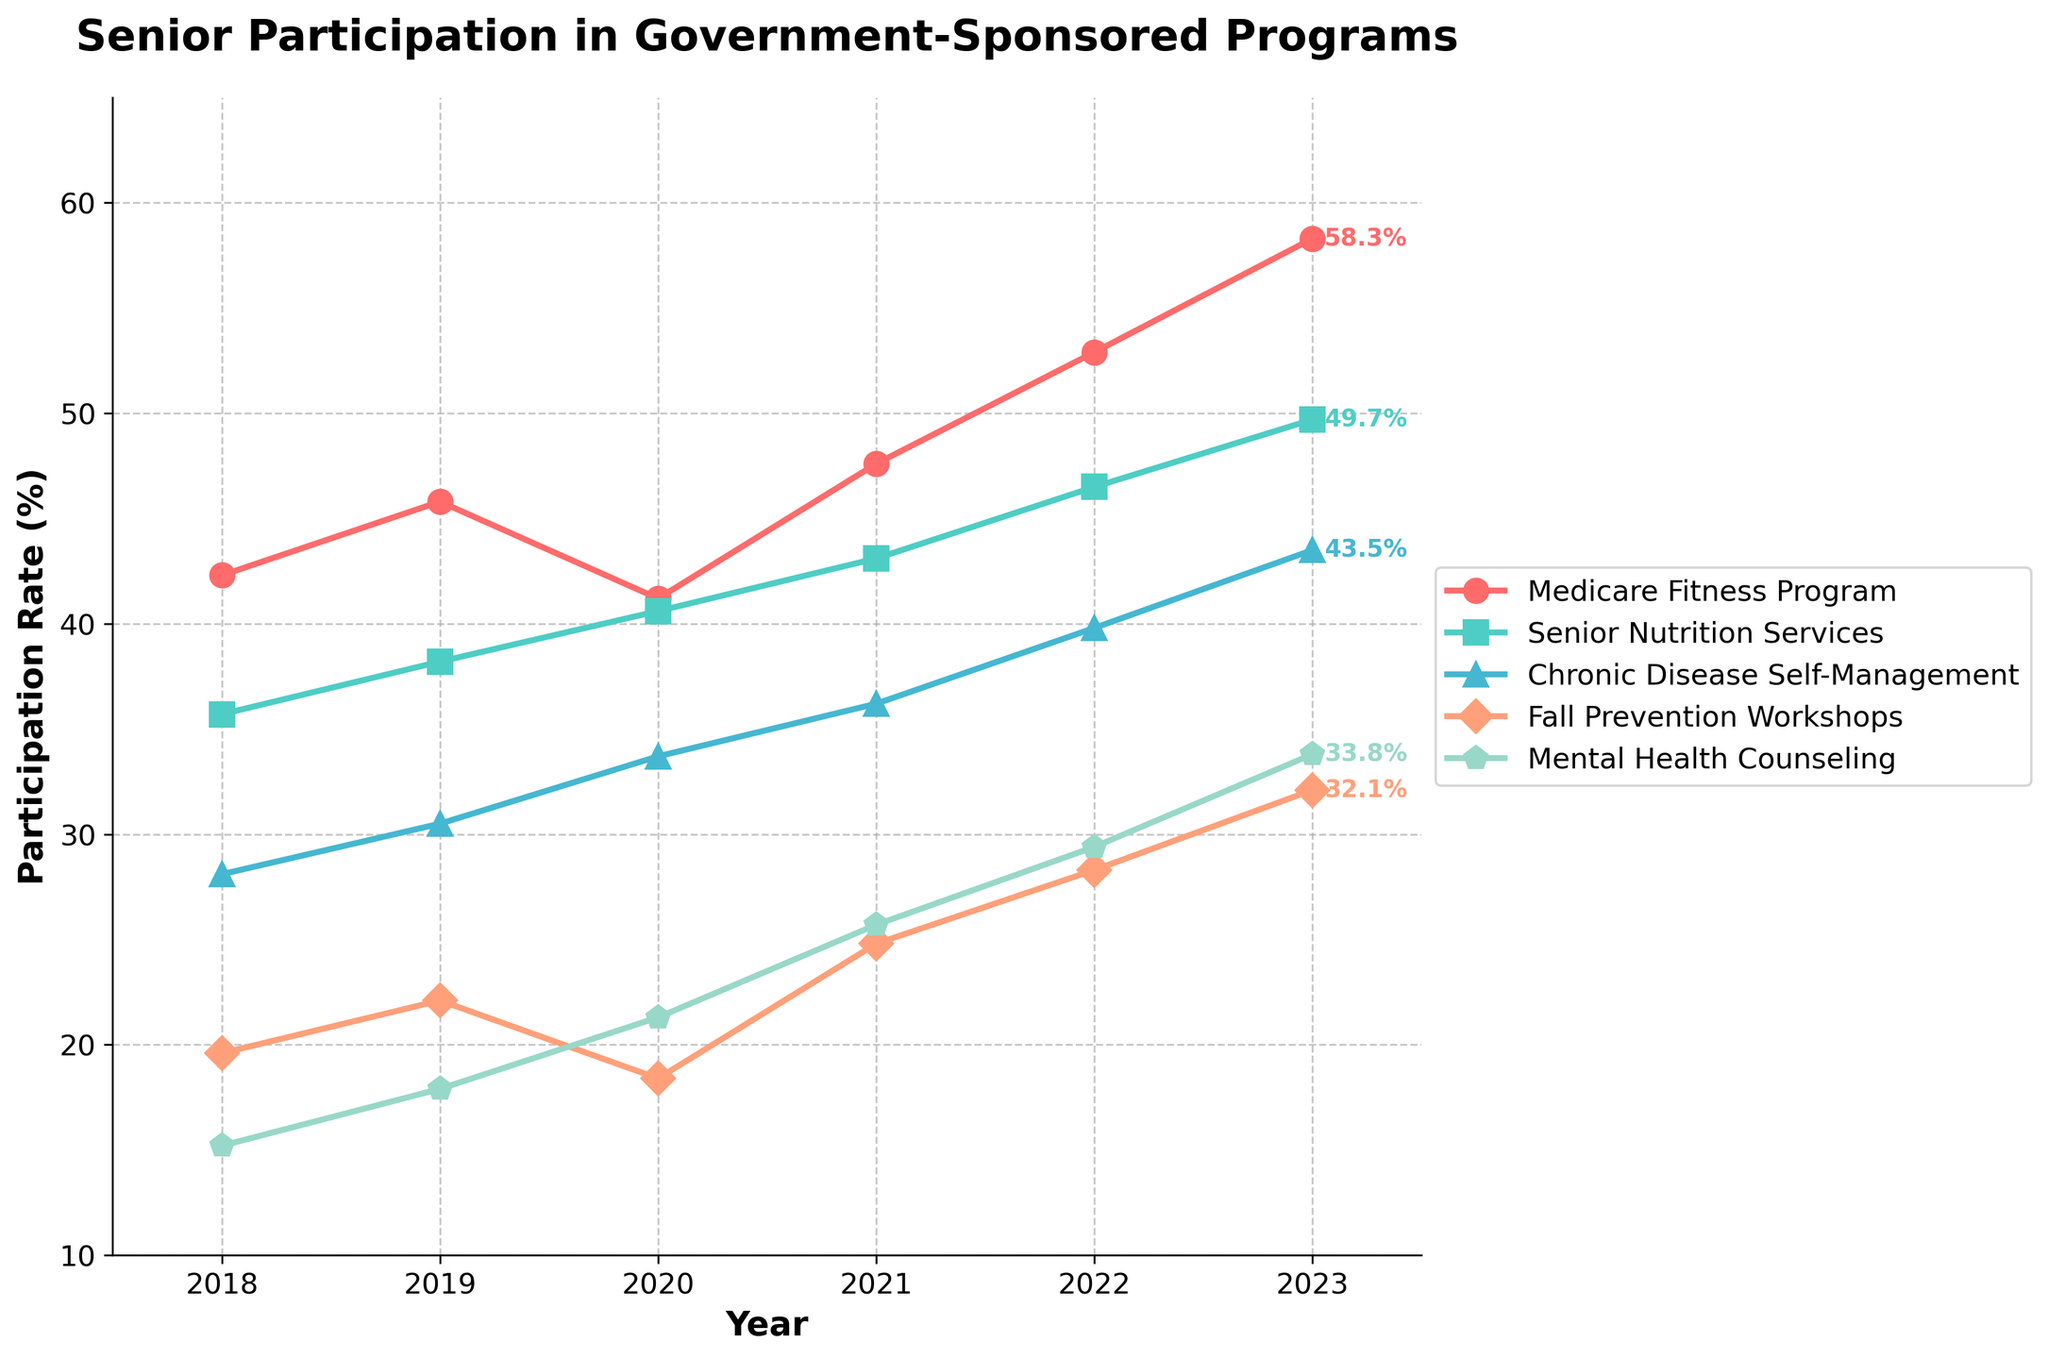What is the overall trend in participation rates of the Medicare Fitness Program from 2018 to 2023? To determine the overall trend of the Medicare Fitness Program's participation rates, look at the starting value in 2018 and the ending value in 2023. The participation rate increases from 42.3% in 2018 to 58.3% in 2023. This indicates an upward trend.
Answer: Increasing Which program had the highest participation rate in 2023? To answer this, check the participation rates of all programs in 2023. The highest participation rate is for the Medicare Fitness Program, at 58.3%.
Answer: Medicare Fitness Program How did the participation rate for Fall Prevention Workshops change from 2019 to 2020? Look at the participation rates for Fall Prevention Workshops in 2019 (22.1%) and 2020 (18.4%). The participation rate decreased by subtracting 18.4 from 22.1, resulting in -3.7%.
Answer: Decrease What is the average participation rate for Mental Health Counseling over the six years from 2018 to 2023? Calculate the average by adding the rates for each year and then dividing by 6. (15.2 + 17.9 + 21.3 + 25.7 + 29.4 + 33.8) / 6 = 143.3 / 6. Therefore, the average rate is approximately 23.9%.
Answer: 23.9% Between which two consecutive years did Chronic Disease Self-Management see the highest growth in participation rates? Compare the yearly differences: 
- 2018 to 2019: 30.5 - 28.1 = 2.4 
- 2019 to 2020: 33.7 - 30.5 = 3.2 
- 2020 to 2021: 36.2 - 33.7 = 2.5 
- 2021 to 2022: 39.8 - 36.2 = 3.6 
- 2022 to 2023: 43.5 - 39.8 = 3.7 
The highest growth is from 2022 to 2023 (+3.7%).
Answer: 2022 to 2023 Which program has the most consistent growth trend from 2018 to 2023? To find the most consistent growth trend, visually inspect the lines. The Medicare Fitness Program line has a relatively steady upward slope, followed by the Mental Health Counseling line. Thus, the Medicare Fitness Program is the most consistent.
Answer: Medicare Fitness Program How does the 2023 participation rate of Senior Nutrition Services compare to its rate in 2018? Compare the 2023 participation rate (49.7%) to the 2018 rate (35.7%). The difference is 49.7 - 35.7 = 14%.
Answer: 14% increase Which program had the least participation rate growth from its lowest point to its highest point during the years provided? Identify the lowest and highest points for each program and calculate the difference. The results are:
- Medicare Fitness Program: 58.3 - 41.2 = 17.1
- Senior Nutrition Services: 49.7 - 35.7 = 14
- Chronic Disease Self-Management: 43.5 - 28.1 = 15.4
- Fall Prevention Workshops: 32.1 - 18.4 = 13.7
- Mental Health Counseling: 33.8 - 15.2 = 18.6
The least growth is for Fall Prevention Workshops (13.7%).
Answer: Fall Prevention Workshops 